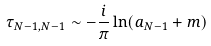<formula> <loc_0><loc_0><loc_500><loc_500>\tau _ { N - 1 , N - 1 } \sim - { \frac { i } { \pi } } \ln ( a _ { N - 1 } + m )</formula> 